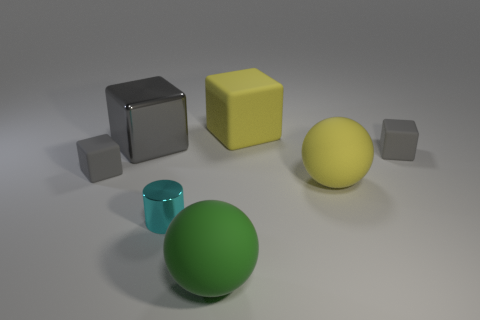What number of other things are there of the same color as the large shiny object?
Keep it short and to the point. 2. What is the shape of the big yellow thing behind the big gray metallic object?
Offer a very short reply. Cube. Is the number of small metal cylinders less than the number of spheres?
Give a very brief answer. Yes. Do the tiny gray cube on the right side of the tiny cyan thing and the cyan cylinder have the same material?
Keep it short and to the point. No. Are there any large green spheres to the left of the tiny cyan cylinder?
Keep it short and to the point. No. There is a small matte object that is on the left side of the big sphere to the left of the yellow rubber thing that is on the right side of the yellow matte cube; what is its color?
Ensure brevity in your answer.  Gray. There is another shiny object that is the same size as the green object; what shape is it?
Provide a succinct answer. Cube. Is the number of big green metallic cylinders greater than the number of things?
Your answer should be compact. No. There is a large cube in front of the yellow matte cube; is there a large cube that is in front of it?
Offer a very short reply. No. There is another large thing that is the same shape as the large green object; what is its color?
Provide a short and direct response. Yellow. 